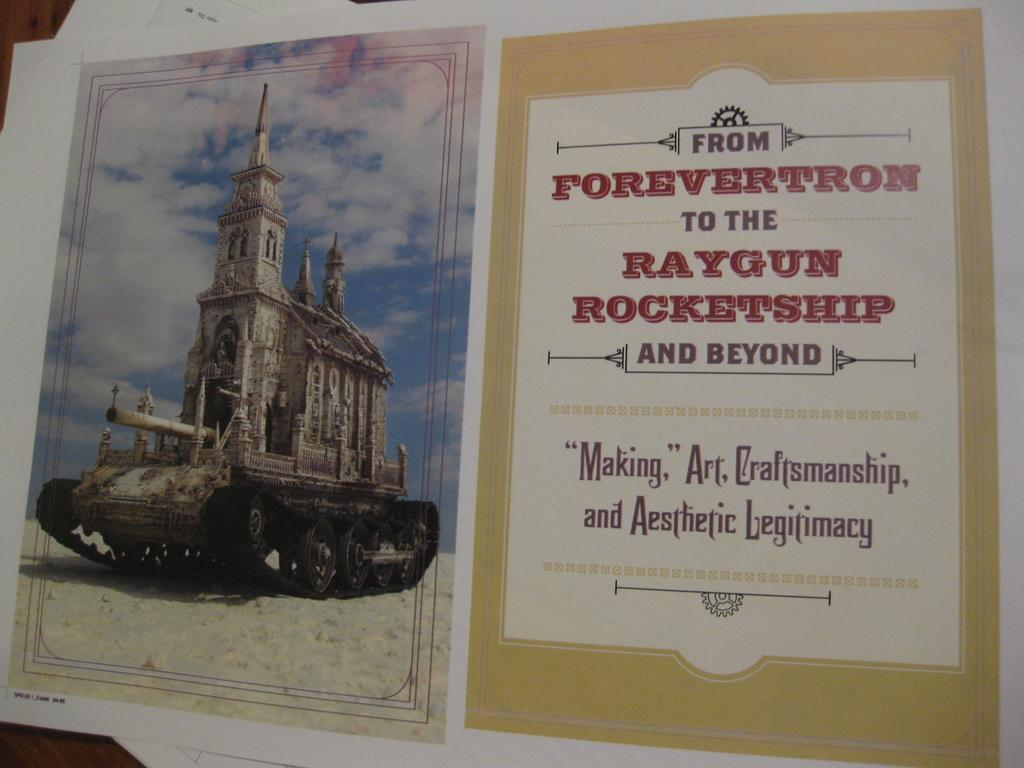Provide a one-sentence caption for the provided image. Paper about from forevertron to the raygun rocketship and beyond. 